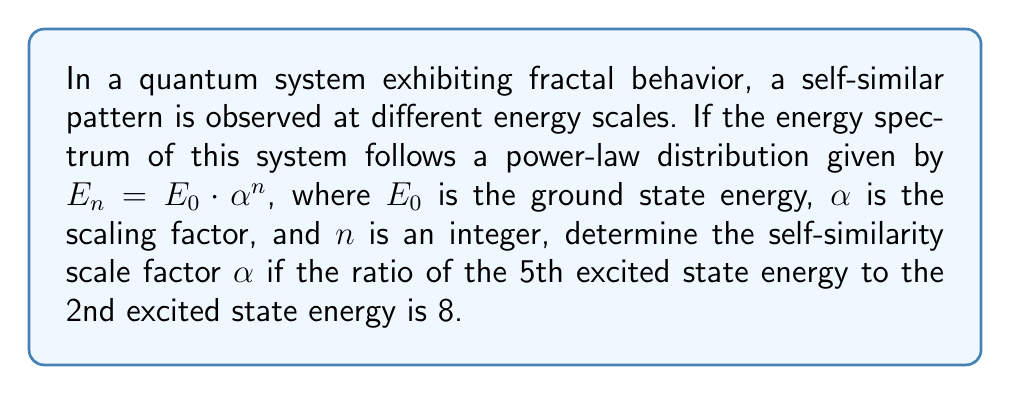Could you help me with this problem? To solve this problem, we need to use the given power-law distribution of the energy spectrum and the relationship between the 5th and 2nd excited states. Let's approach this step-by-step:

1) The energy spectrum is given by $E_n = E_0 \cdot \alpha^n$, where $n$ is the energy level (starting from 0 for the ground state).

2) The 2nd excited state corresponds to $n=2$, and the 5th excited state corresponds to $n=5$.

3) Let's express the energies of these states:
   
   $E_2 = E_0 \cdot \alpha^2$
   $E_5 = E_0 \cdot \alpha^5$

4) We're told that the ratio of these energies is 8:

   $$\frac{E_5}{E_2} = 8$$

5) Let's substitute the expressions for $E_5$ and $E_2$:

   $$\frac{E_0 \cdot \alpha^5}{E_0 \cdot \alpha^2} = 8$$

6) The $E_0$ terms cancel out:

   $$\frac{\alpha^5}{\alpha^2} = 8$$

7) Simplify the left side:

   $$\alpha^{5-2} = \alpha^3 = 8$$

8) To solve for $\alpha$, we need to take the cube root of both sides:

   $$\alpha = \sqrt[3]{8} = 2$$

Thus, the self-similarity scale factor $\alpha$ is 2.

This result aligns with the concept of scale invariance in fractal systems, where patterns repeat at different scales. In this quantum system, the energy levels scale by a factor of 2 between similar states, reflecting the self-similarity characteristic of fractals.
Answer: $\alpha = 2$ 